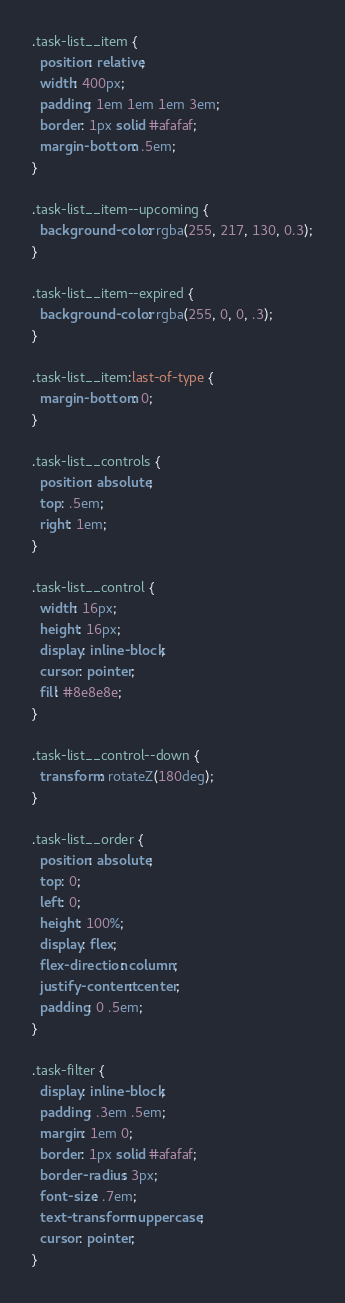Convert code to text. <code><loc_0><loc_0><loc_500><loc_500><_CSS_>.task-list__item {
  position: relative;
  width: 400px;
  padding: 1em 1em 1em 3em;
  border: 1px solid #afafaf;
  margin-bottom: .5em;
}

.task-list__item--upcoming {
  background-color: rgba(255, 217, 130, 0.3);
}

.task-list__item--expired {
  background-color: rgba(255, 0, 0, .3);
}

.task-list__item:last-of-type {
  margin-bottom: 0;
}

.task-list__controls {
  position: absolute;
  top: .5em;
  right: 1em;
}

.task-list__control {
  width: 16px;
  height: 16px;
  display: inline-block;
  cursor: pointer;
  fill: #8e8e8e;
}

.task-list__control--down {
  transform: rotateZ(180deg);
}

.task-list__order {
  position: absolute;
  top: 0;
  left: 0;
  height: 100%;
  display: flex;
  flex-direction: column;
  justify-content: center;
  padding: 0 .5em;
}

.task-filter {
  display: inline-block;
  padding: .3em .5em;
  margin: 1em 0;
  border: 1px solid #afafaf;
  border-radius: 3px;
  font-size: .7em;
  text-transform: uppercase;
  cursor: pointer;
}
</code> 